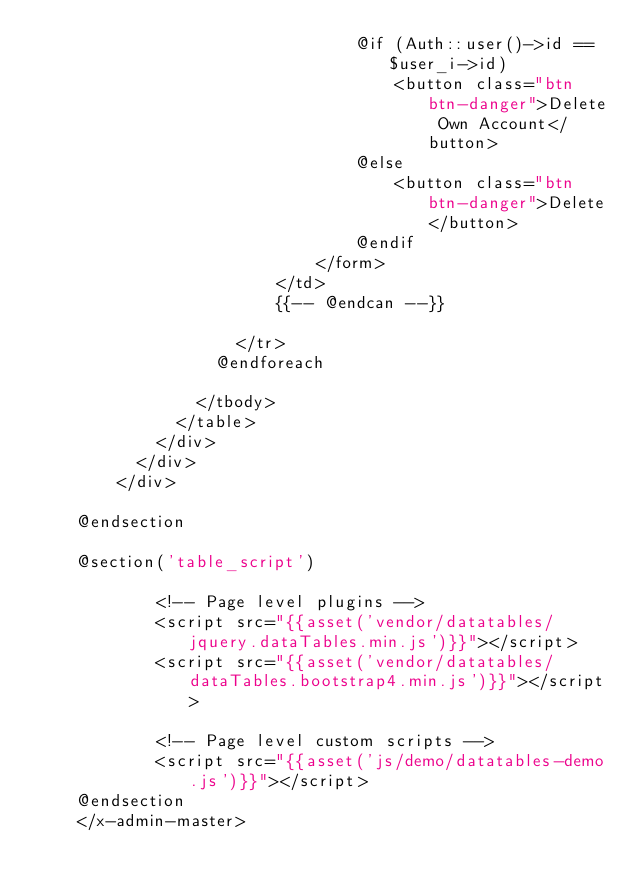Convert code to text. <code><loc_0><loc_0><loc_500><loc_500><_PHP_>                                @if (Auth::user()->id == $user_i->id)
                                    <button class="btn btn-danger">Delete Own Account</button>
                                @else
                                    <button class="btn btn-danger">Delete</button>
                                @endif
                            </form>
                        </td>
                        {{-- @endcan --}}
    
                    </tr>
                  @endforeach
                  
                </tbody>
              </table>
            </div>
          </div>
        </div>
    
    @endsection
    
    @section('table_script')
    
            <!-- Page level plugins -->
            <script src="{{asset('vendor/datatables/jquery.dataTables.min.js')}}"></script>
            <script src="{{asset('vendor/datatables/dataTables.bootstrap4.min.js')}}"></script>
    
            <!-- Page level custom scripts -->
            <script src="{{asset('js/demo/datatables-demo.js')}}"></script>
    @endsection
    </x-admin-master>
    </code> 